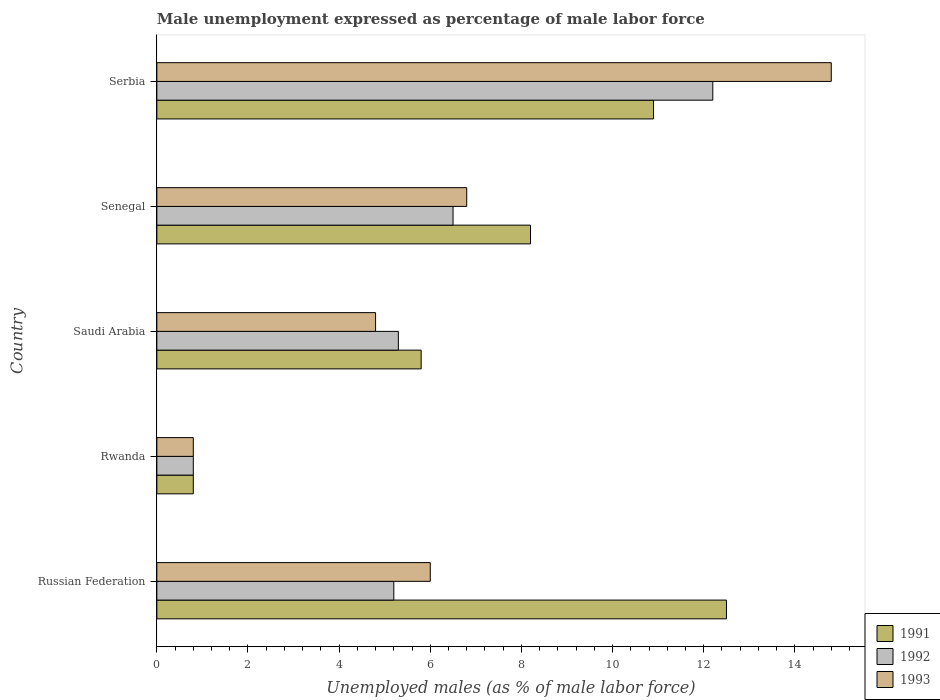How many bars are there on the 1st tick from the bottom?
Your answer should be compact. 3. What is the label of the 5th group of bars from the top?
Your response must be concise. Russian Federation. In how many cases, is the number of bars for a given country not equal to the number of legend labels?
Make the answer very short. 0. What is the unemployment in males in in 1991 in Rwanda?
Provide a succinct answer. 0.8. Across all countries, what is the maximum unemployment in males in in 1991?
Provide a short and direct response. 12.5. Across all countries, what is the minimum unemployment in males in in 1992?
Your response must be concise. 0.8. In which country was the unemployment in males in in 1991 maximum?
Make the answer very short. Russian Federation. In which country was the unemployment in males in in 1992 minimum?
Make the answer very short. Rwanda. What is the total unemployment in males in in 1991 in the graph?
Your answer should be compact. 38.2. What is the difference between the unemployment in males in in 1992 in Russian Federation and that in Rwanda?
Ensure brevity in your answer.  4.4. What is the difference between the unemployment in males in in 1991 in Russian Federation and the unemployment in males in in 1993 in Serbia?
Provide a succinct answer. -2.3. What is the average unemployment in males in in 1991 per country?
Provide a short and direct response. 7.64. In how many countries, is the unemployment in males in in 1993 greater than 8.4 %?
Provide a short and direct response. 1. What is the ratio of the unemployment in males in in 1993 in Russian Federation to that in Serbia?
Keep it short and to the point. 0.41. Is the unemployment in males in in 1991 in Russian Federation less than that in Senegal?
Ensure brevity in your answer.  No. What is the difference between the highest and the second highest unemployment in males in in 1993?
Offer a very short reply. 8. What is the difference between the highest and the lowest unemployment in males in in 1993?
Make the answer very short. 14. What does the 3rd bar from the bottom in Rwanda represents?
Make the answer very short. 1993. Is it the case that in every country, the sum of the unemployment in males in in 1991 and unemployment in males in in 1993 is greater than the unemployment in males in in 1992?
Your answer should be compact. Yes. How many countries are there in the graph?
Provide a succinct answer. 5. What is the difference between two consecutive major ticks on the X-axis?
Offer a very short reply. 2. How are the legend labels stacked?
Offer a very short reply. Vertical. What is the title of the graph?
Keep it short and to the point. Male unemployment expressed as percentage of male labor force. Does "1963" appear as one of the legend labels in the graph?
Offer a very short reply. No. What is the label or title of the X-axis?
Offer a terse response. Unemployed males (as % of male labor force). What is the label or title of the Y-axis?
Offer a terse response. Country. What is the Unemployed males (as % of male labor force) of 1992 in Russian Federation?
Provide a short and direct response. 5.2. What is the Unemployed males (as % of male labor force) in 1991 in Rwanda?
Ensure brevity in your answer.  0.8. What is the Unemployed males (as % of male labor force) of 1992 in Rwanda?
Make the answer very short. 0.8. What is the Unemployed males (as % of male labor force) in 1993 in Rwanda?
Keep it short and to the point. 0.8. What is the Unemployed males (as % of male labor force) in 1991 in Saudi Arabia?
Give a very brief answer. 5.8. What is the Unemployed males (as % of male labor force) in 1992 in Saudi Arabia?
Make the answer very short. 5.3. What is the Unemployed males (as % of male labor force) of 1993 in Saudi Arabia?
Give a very brief answer. 4.8. What is the Unemployed males (as % of male labor force) in 1991 in Senegal?
Give a very brief answer. 8.2. What is the Unemployed males (as % of male labor force) in 1993 in Senegal?
Give a very brief answer. 6.8. What is the Unemployed males (as % of male labor force) in 1991 in Serbia?
Provide a short and direct response. 10.9. What is the Unemployed males (as % of male labor force) in 1992 in Serbia?
Your answer should be very brief. 12.2. What is the Unemployed males (as % of male labor force) of 1993 in Serbia?
Keep it short and to the point. 14.8. Across all countries, what is the maximum Unemployed males (as % of male labor force) of 1991?
Offer a very short reply. 12.5. Across all countries, what is the maximum Unemployed males (as % of male labor force) in 1992?
Your response must be concise. 12.2. Across all countries, what is the maximum Unemployed males (as % of male labor force) in 1993?
Provide a short and direct response. 14.8. Across all countries, what is the minimum Unemployed males (as % of male labor force) of 1991?
Offer a terse response. 0.8. Across all countries, what is the minimum Unemployed males (as % of male labor force) in 1992?
Offer a very short reply. 0.8. Across all countries, what is the minimum Unemployed males (as % of male labor force) of 1993?
Give a very brief answer. 0.8. What is the total Unemployed males (as % of male labor force) of 1991 in the graph?
Your response must be concise. 38.2. What is the total Unemployed males (as % of male labor force) of 1993 in the graph?
Offer a very short reply. 33.2. What is the difference between the Unemployed males (as % of male labor force) of 1991 in Russian Federation and that in Rwanda?
Your answer should be very brief. 11.7. What is the difference between the Unemployed males (as % of male labor force) of 1992 in Russian Federation and that in Rwanda?
Offer a very short reply. 4.4. What is the difference between the Unemployed males (as % of male labor force) in 1991 in Russian Federation and that in Saudi Arabia?
Offer a very short reply. 6.7. What is the difference between the Unemployed males (as % of male labor force) in 1993 in Russian Federation and that in Saudi Arabia?
Your answer should be compact. 1.2. What is the difference between the Unemployed males (as % of male labor force) in 1991 in Russian Federation and that in Senegal?
Provide a short and direct response. 4.3. What is the difference between the Unemployed males (as % of male labor force) in 1992 in Russian Federation and that in Senegal?
Offer a very short reply. -1.3. What is the difference between the Unemployed males (as % of male labor force) of 1993 in Russian Federation and that in Senegal?
Give a very brief answer. -0.8. What is the difference between the Unemployed males (as % of male labor force) in 1991 in Russian Federation and that in Serbia?
Your answer should be very brief. 1.6. What is the difference between the Unemployed males (as % of male labor force) in 1992 in Russian Federation and that in Serbia?
Ensure brevity in your answer.  -7. What is the difference between the Unemployed males (as % of male labor force) of 1993 in Russian Federation and that in Serbia?
Offer a very short reply. -8.8. What is the difference between the Unemployed males (as % of male labor force) in 1991 in Rwanda and that in Senegal?
Your answer should be very brief. -7.4. What is the difference between the Unemployed males (as % of male labor force) in 1992 in Rwanda and that in Senegal?
Make the answer very short. -5.7. What is the difference between the Unemployed males (as % of male labor force) of 1992 in Saudi Arabia and that in Senegal?
Offer a terse response. -1.2. What is the difference between the Unemployed males (as % of male labor force) in 1993 in Saudi Arabia and that in Serbia?
Keep it short and to the point. -10. What is the difference between the Unemployed males (as % of male labor force) in 1991 in Senegal and that in Serbia?
Your response must be concise. -2.7. What is the difference between the Unemployed males (as % of male labor force) of 1991 in Russian Federation and the Unemployed males (as % of male labor force) of 1992 in Rwanda?
Ensure brevity in your answer.  11.7. What is the difference between the Unemployed males (as % of male labor force) of 1991 in Russian Federation and the Unemployed males (as % of male labor force) of 1993 in Saudi Arabia?
Make the answer very short. 7.7. What is the difference between the Unemployed males (as % of male labor force) of 1991 in Russian Federation and the Unemployed males (as % of male labor force) of 1993 in Senegal?
Offer a terse response. 5.7. What is the difference between the Unemployed males (as % of male labor force) of 1991 in Russian Federation and the Unemployed males (as % of male labor force) of 1992 in Serbia?
Your response must be concise. 0.3. What is the difference between the Unemployed males (as % of male labor force) of 1992 in Russian Federation and the Unemployed males (as % of male labor force) of 1993 in Serbia?
Offer a very short reply. -9.6. What is the difference between the Unemployed males (as % of male labor force) in 1991 in Rwanda and the Unemployed males (as % of male labor force) in 1992 in Saudi Arabia?
Keep it short and to the point. -4.5. What is the difference between the Unemployed males (as % of male labor force) of 1991 in Rwanda and the Unemployed males (as % of male labor force) of 1993 in Saudi Arabia?
Keep it short and to the point. -4. What is the difference between the Unemployed males (as % of male labor force) of 1992 in Rwanda and the Unemployed males (as % of male labor force) of 1993 in Saudi Arabia?
Keep it short and to the point. -4. What is the difference between the Unemployed males (as % of male labor force) of 1992 in Rwanda and the Unemployed males (as % of male labor force) of 1993 in Senegal?
Ensure brevity in your answer.  -6. What is the difference between the Unemployed males (as % of male labor force) of 1991 in Rwanda and the Unemployed males (as % of male labor force) of 1992 in Serbia?
Offer a very short reply. -11.4. What is the difference between the Unemployed males (as % of male labor force) in 1991 in Saudi Arabia and the Unemployed males (as % of male labor force) in 1993 in Senegal?
Offer a very short reply. -1. What is the difference between the Unemployed males (as % of male labor force) of 1991 in Saudi Arabia and the Unemployed males (as % of male labor force) of 1992 in Serbia?
Offer a very short reply. -6.4. What is the difference between the Unemployed males (as % of male labor force) in 1991 in Senegal and the Unemployed males (as % of male labor force) in 1992 in Serbia?
Make the answer very short. -4. What is the difference between the Unemployed males (as % of male labor force) in 1991 in Senegal and the Unemployed males (as % of male labor force) in 1993 in Serbia?
Keep it short and to the point. -6.6. What is the difference between the Unemployed males (as % of male labor force) in 1992 in Senegal and the Unemployed males (as % of male labor force) in 1993 in Serbia?
Give a very brief answer. -8.3. What is the average Unemployed males (as % of male labor force) in 1991 per country?
Provide a short and direct response. 7.64. What is the average Unemployed males (as % of male labor force) of 1993 per country?
Keep it short and to the point. 6.64. What is the difference between the Unemployed males (as % of male labor force) in 1991 and Unemployed males (as % of male labor force) in 1992 in Russian Federation?
Your answer should be compact. 7.3. What is the difference between the Unemployed males (as % of male labor force) in 1992 and Unemployed males (as % of male labor force) in 1993 in Russian Federation?
Provide a short and direct response. -0.8. What is the difference between the Unemployed males (as % of male labor force) of 1991 and Unemployed males (as % of male labor force) of 1993 in Rwanda?
Offer a very short reply. 0. What is the difference between the Unemployed males (as % of male labor force) in 1992 and Unemployed males (as % of male labor force) in 1993 in Rwanda?
Offer a very short reply. 0. What is the difference between the Unemployed males (as % of male labor force) of 1991 and Unemployed males (as % of male labor force) of 1992 in Saudi Arabia?
Make the answer very short. 0.5. What is the difference between the Unemployed males (as % of male labor force) of 1992 and Unemployed males (as % of male labor force) of 1993 in Saudi Arabia?
Provide a short and direct response. 0.5. What is the difference between the Unemployed males (as % of male labor force) of 1991 and Unemployed males (as % of male labor force) of 1992 in Senegal?
Provide a short and direct response. 1.7. What is the difference between the Unemployed males (as % of male labor force) in 1991 and Unemployed males (as % of male labor force) in 1993 in Senegal?
Provide a short and direct response. 1.4. What is the difference between the Unemployed males (as % of male labor force) of 1992 and Unemployed males (as % of male labor force) of 1993 in Senegal?
Provide a succinct answer. -0.3. What is the difference between the Unemployed males (as % of male labor force) in 1991 and Unemployed males (as % of male labor force) in 1993 in Serbia?
Give a very brief answer. -3.9. What is the ratio of the Unemployed males (as % of male labor force) in 1991 in Russian Federation to that in Rwanda?
Your answer should be very brief. 15.62. What is the ratio of the Unemployed males (as % of male labor force) in 1992 in Russian Federation to that in Rwanda?
Your answer should be very brief. 6.5. What is the ratio of the Unemployed males (as % of male labor force) in 1993 in Russian Federation to that in Rwanda?
Give a very brief answer. 7.5. What is the ratio of the Unemployed males (as % of male labor force) of 1991 in Russian Federation to that in Saudi Arabia?
Keep it short and to the point. 2.16. What is the ratio of the Unemployed males (as % of male labor force) of 1992 in Russian Federation to that in Saudi Arabia?
Ensure brevity in your answer.  0.98. What is the ratio of the Unemployed males (as % of male labor force) in 1991 in Russian Federation to that in Senegal?
Offer a very short reply. 1.52. What is the ratio of the Unemployed males (as % of male labor force) of 1993 in Russian Federation to that in Senegal?
Make the answer very short. 0.88. What is the ratio of the Unemployed males (as % of male labor force) of 1991 in Russian Federation to that in Serbia?
Give a very brief answer. 1.15. What is the ratio of the Unemployed males (as % of male labor force) of 1992 in Russian Federation to that in Serbia?
Ensure brevity in your answer.  0.43. What is the ratio of the Unemployed males (as % of male labor force) of 1993 in Russian Federation to that in Serbia?
Your answer should be compact. 0.41. What is the ratio of the Unemployed males (as % of male labor force) of 1991 in Rwanda to that in Saudi Arabia?
Offer a very short reply. 0.14. What is the ratio of the Unemployed males (as % of male labor force) of 1992 in Rwanda to that in Saudi Arabia?
Your answer should be compact. 0.15. What is the ratio of the Unemployed males (as % of male labor force) in 1993 in Rwanda to that in Saudi Arabia?
Your response must be concise. 0.17. What is the ratio of the Unemployed males (as % of male labor force) of 1991 in Rwanda to that in Senegal?
Give a very brief answer. 0.1. What is the ratio of the Unemployed males (as % of male labor force) in 1992 in Rwanda to that in Senegal?
Your answer should be compact. 0.12. What is the ratio of the Unemployed males (as % of male labor force) of 1993 in Rwanda to that in Senegal?
Your answer should be very brief. 0.12. What is the ratio of the Unemployed males (as % of male labor force) in 1991 in Rwanda to that in Serbia?
Make the answer very short. 0.07. What is the ratio of the Unemployed males (as % of male labor force) of 1992 in Rwanda to that in Serbia?
Offer a very short reply. 0.07. What is the ratio of the Unemployed males (as % of male labor force) of 1993 in Rwanda to that in Serbia?
Your answer should be compact. 0.05. What is the ratio of the Unemployed males (as % of male labor force) of 1991 in Saudi Arabia to that in Senegal?
Keep it short and to the point. 0.71. What is the ratio of the Unemployed males (as % of male labor force) of 1992 in Saudi Arabia to that in Senegal?
Offer a very short reply. 0.82. What is the ratio of the Unemployed males (as % of male labor force) of 1993 in Saudi Arabia to that in Senegal?
Give a very brief answer. 0.71. What is the ratio of the Unemployed males (as % of male labor force) in 1991 in Saudi Arabia to that in Serbia?
Offer a very short reply. 0.53. What is the ratio of the Unemployed males (as % of male labor force) of 1992 in Saudi Arabia to that in Serbia?
Your answer should be compact. 0.43. What is the ratio of the Unemployed males (as % of male labor force) in 1993 in Saudi Arabia to that in Serbia?
Provide a succinct answer. 0.32. What is the ratio of the Unemployed males (as % of male labor force) of 1991 in Senegal to that in Serbia?
Offer a terse response. 0.75. What is the ratio of the Unemployed males (as % of male labor force) of 1992 in Senegal to that in Serbia?
Keep it short and to the point. 0.53. What is the ratio of the Unemployed males (as % of male labor force) of 1993 in Senegal to that in Serbia?
Offer a terse response. 0.46. What is the difference between the highest and the second highest Unemployed males (as % of male labor force) in 1991?
Offer a terse response. 1.6. What is the difference between the highest and the second highest Unemployed males (as % of male labor force) in 1992?
Ensure brevity in your answer.  5.7. What is the difference between the highest and the lowest Unemployed males (as % of male labor force) in 1991?
Offer a terse response. 11.7. 